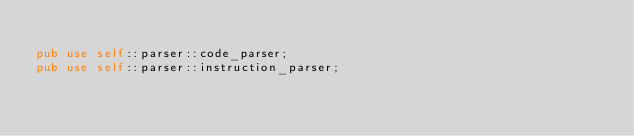<code> <loc_0><loc_0><loc_500><loc_500><_Rust_>
pub use self::parser::code_parser;
pub use self::parser::instruction_parser;
</code> 